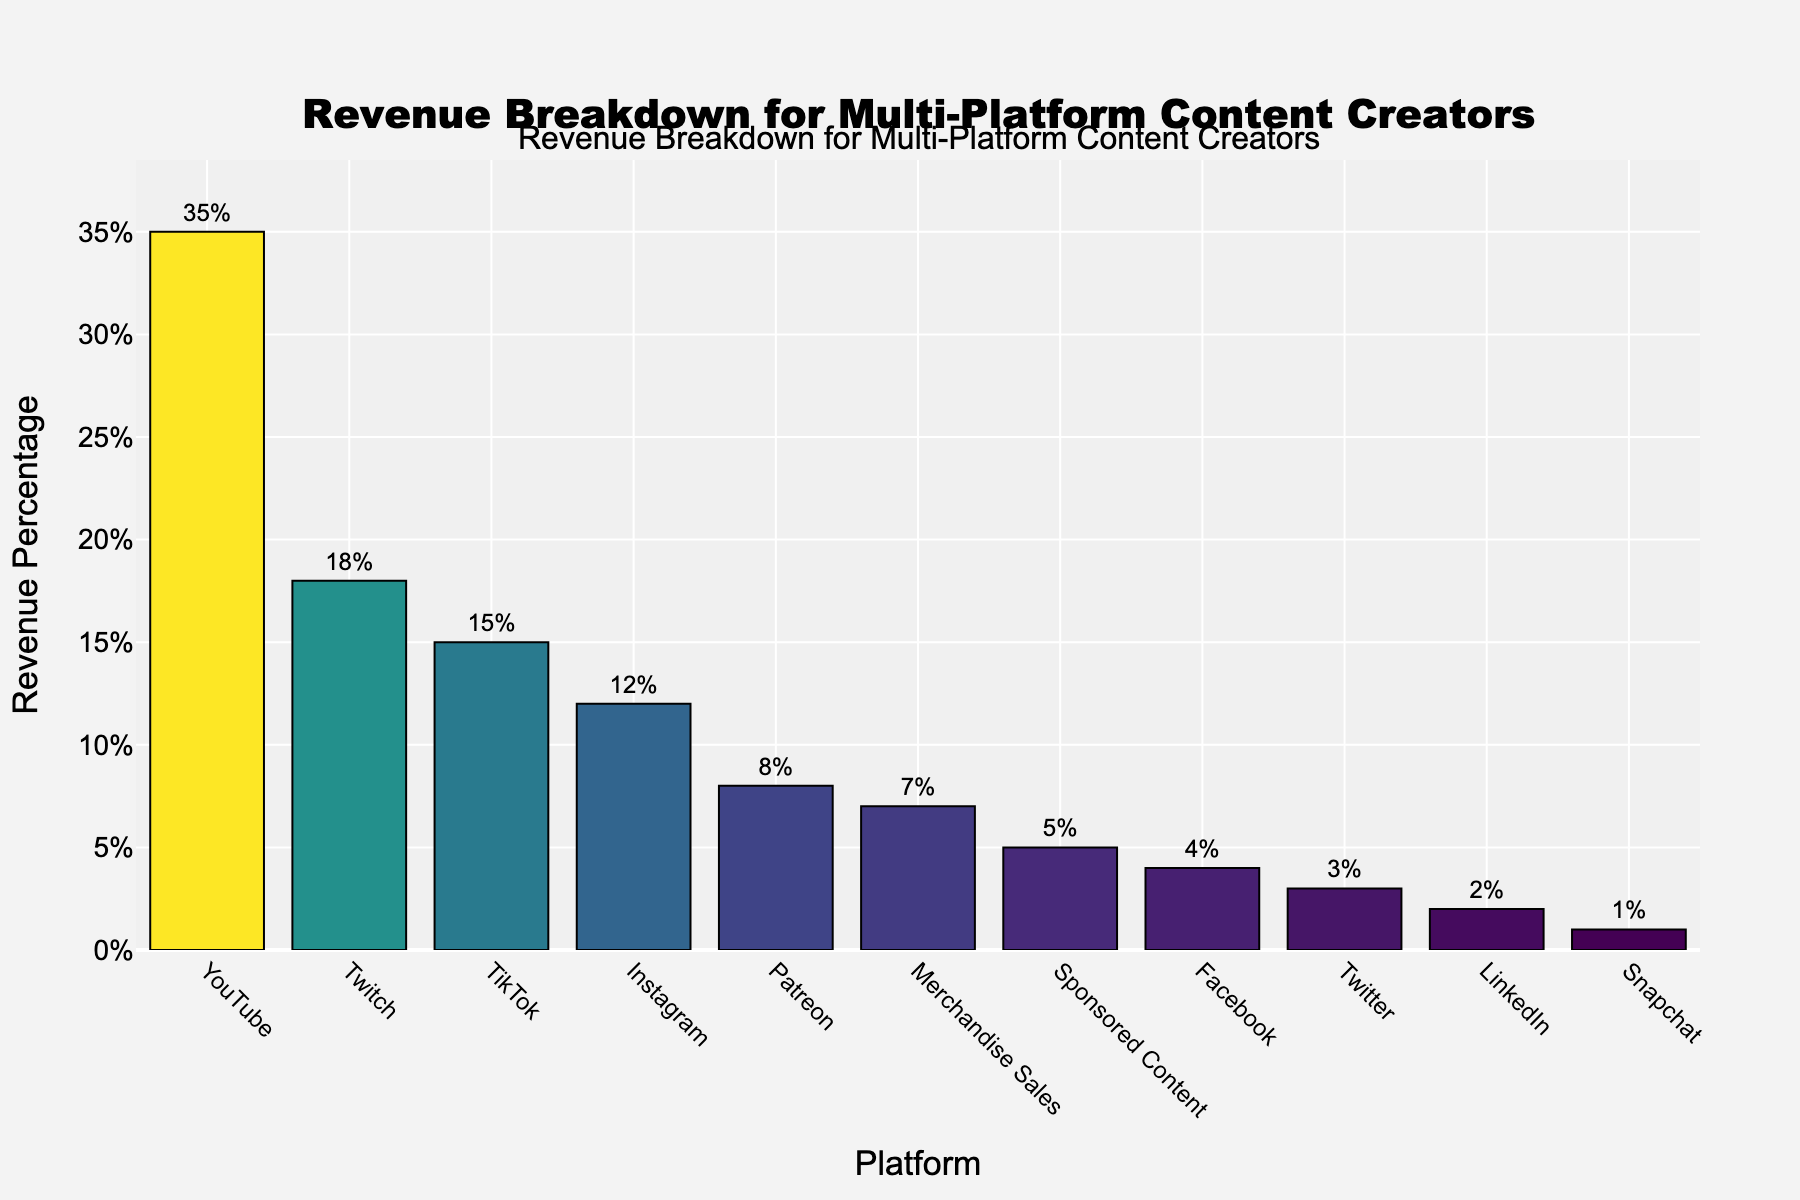Which platform contributes the most to the revenue? The platform with the tallest bar corresponds to the largest revenue percentage. In the figure, YouTube has the tallest bar.
Answer: YouTube What is the combined revenue percentage of TikTok and Patreon? Find the bars for TikTok and Patreon and add their revenue percentages. TikTok is 15% and Patreon is 8%, so 15% + 8% = 23%.
Answer: 23% How does the revenue from Instagram compare to that from Merchandise Sales? Locate the bars for Instagram and Merchandise Sales. Instagram has 12%, while Merchandise Sales has 7%. Since 12% is greater than 7%, Instagram generates more revenue than Merchandise Sales.
Answer: Instagram generates more Which platform generates the least revenue? Identify the bar with the smallest height, which represents the smallest revenue percentage. In the figure, Snapchat has the smallest bar.
Answer: Snapchat What is the sum of the revenue percentages for platforms with less than 5% revenue? Identify all platforms with bars lower than the 5% mark. These are Facebook (4%), Twitter (3%), LinkedIn (2%), and Snapchat (1%). Add their percentages: 4% + 3% + 2% + 1% = 10%.
Answer: 10% What percentage of revenue is contributed by YouTube and Instagram combined? Add the revenue percentages of YouTube and Instagram. YouTube has 35% and Instagram has 12%, so 35% + 12% = 47%.
Answer: 47% Which platform has exactly half the revenue percentage of YouTube? Determine half of YouTube's revenue percentage, which is 35% / 2 = 17.5%. No platform has exactly 17.5%, but Twitch is close with 18%.
Answer: None exactly, closest is Twitch Is there any platform generating exactly 5% of the revenue? Look for a bar labeled with a 5% revenue percentage. In the figure, Sponsored Content has exactly 5%.
Answer: Sponsored Content What is the revenue percentage difference between Twitch and TikTok? Subtract TikTok's revenue percentage from Twitch's. Twitch has 18% and TikTok has 15%, so 18% - 15% = 3%.
Answer: 3% How many platforms generate more than 10% of the revenue? Count the bars with revenue percentages greater than 10%. These are YouTube (35%), Twitch (18%), TikTok (15%), and Instagram (12%). So, 4 platforms.
Answer: 4 